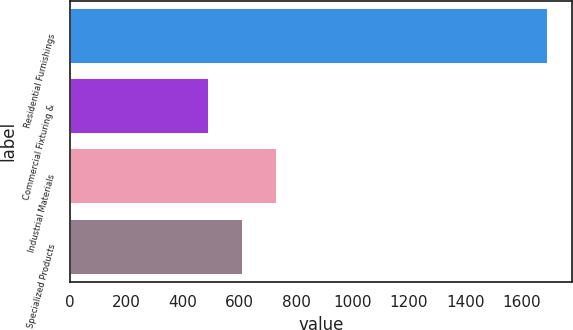<chart> <loc_0><loc_0><loc_500><loc_500><bar_chart><fcel>Residential Furnishings<fcel>Commercial Fixturing &<fcel>Industrial Materials<fcel>Specialized Products<nl><fcel>1693.2<fcel>491.4<fcel>731.76<fcel>611.58<nl></chart> 